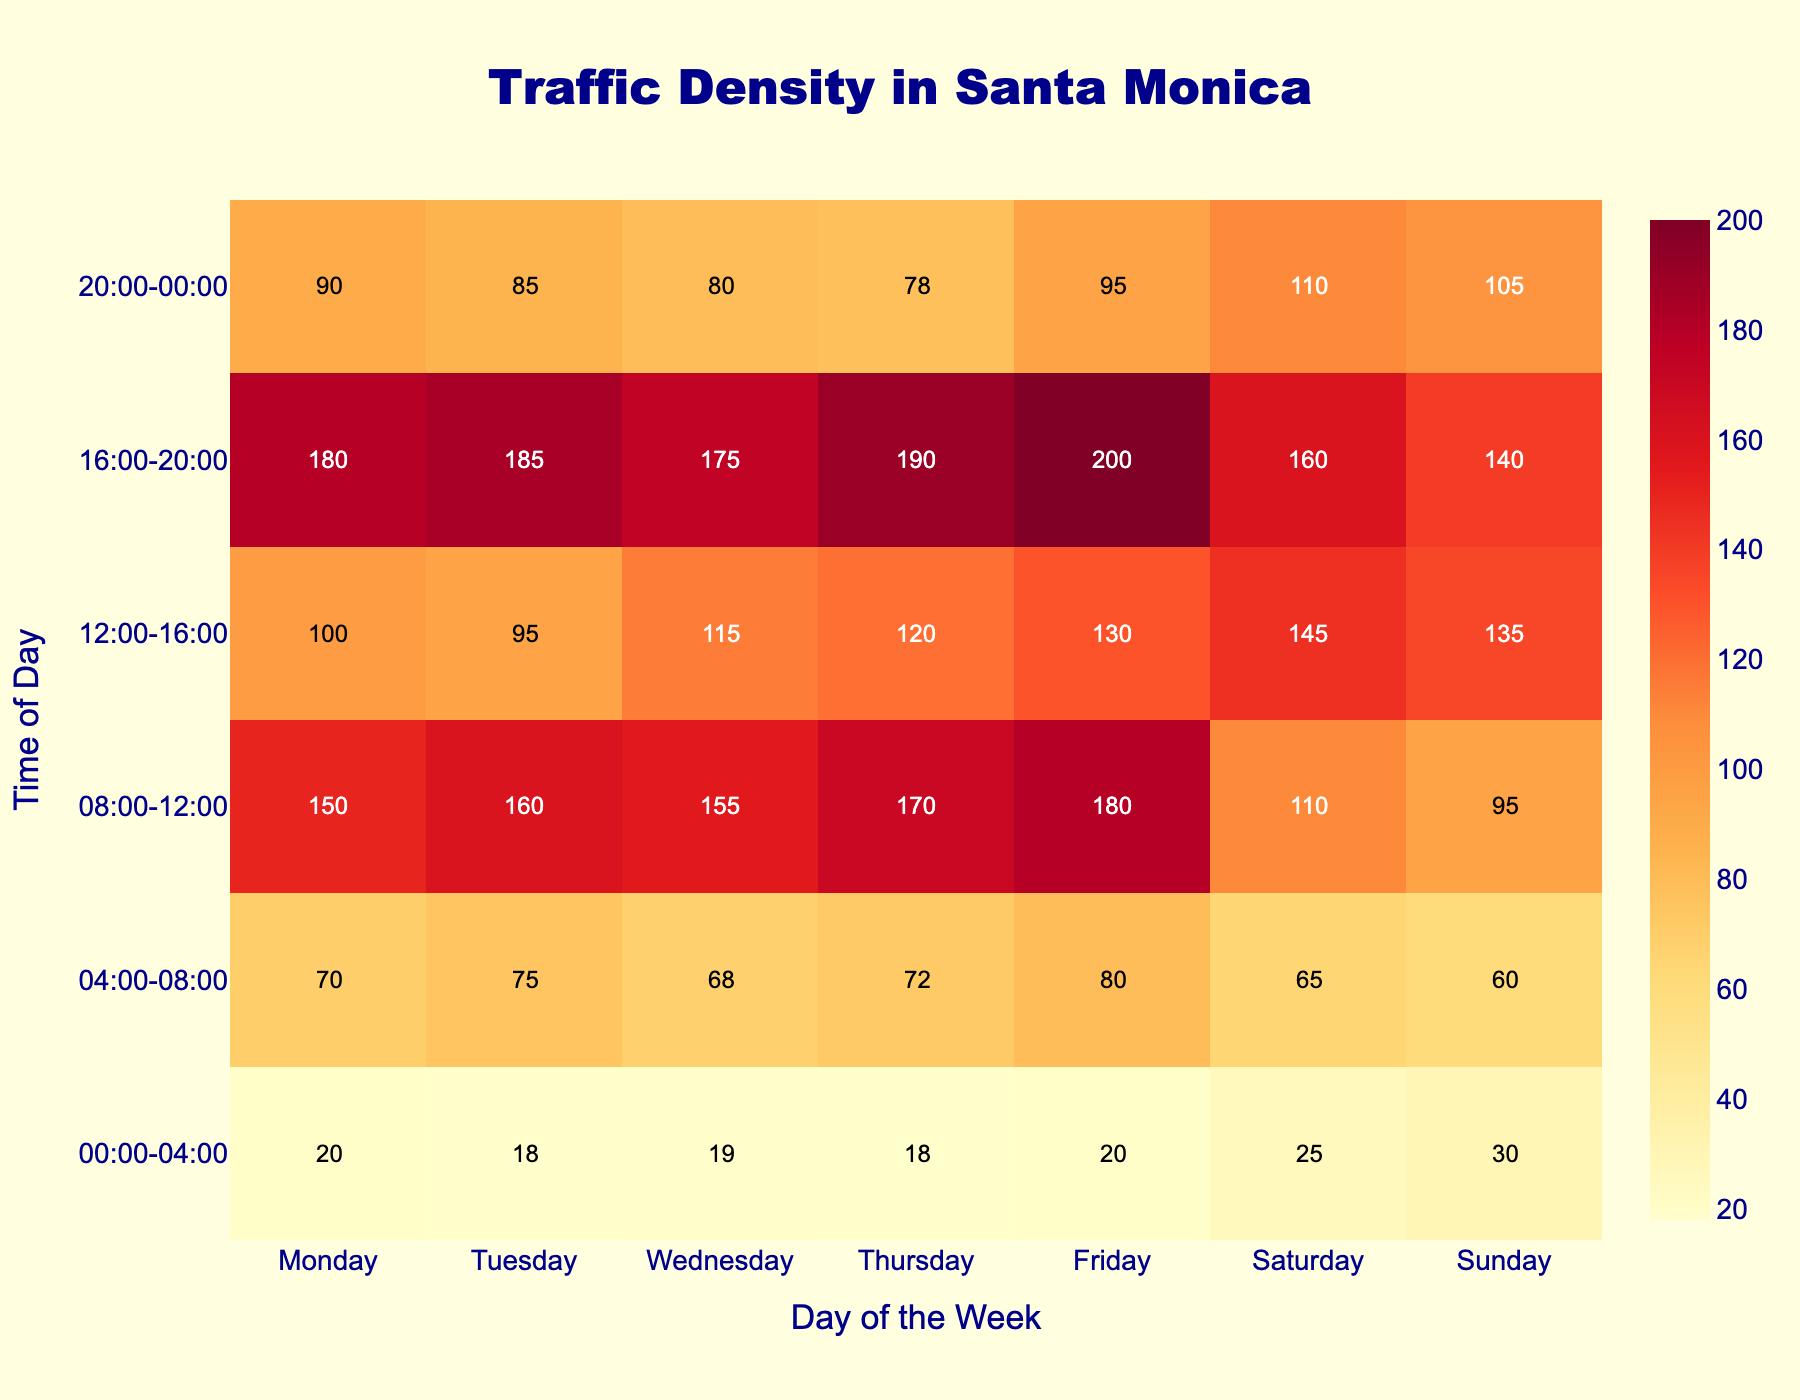What time period shows the highest traffic density on Friday? Looking at the heatmap, find the cell with the highest value under Friday. The highest number is 200, which is in the row corresponding to the 16:00-20:00 time period.
Answer: 16:00-20:00 Which day has the lowest average traffic density over all time periods? Calculate the average traffic density for each day by summing the values for each column and dividing by the number of time periods (6). The averages are: Monday (101.67), Tuesday (104.17), Wednesday (102.00), Thursday (108.00), Friday (117.50), Saturday (102.50), and Sunday (93.33). The lowest average is on Sunday.
Answer: Sunday How does the traffic density at 08:00-12:00 on weekdays compare to weekends? Average the values in the 08:00-12:00 row for weekdays (Monday to Friday) and compare it with the average for weekends (Saturday and Sunday). Weekdays: (150+160+155+170+180)/5 = 163. Weekends: (110+95)/2 = 102.5. Weekday traffic density is higher.
Answer: Weekdays are higher What is the difference in traffic density between Tuesday and Thursday at 12:00-16:00? Subtract the traffic density on Tuesday at 12:00-16:00 from the density on Thursday at the same time. 120 (Thursday) - 95 (Tuesday) = 25.
Answer: 25 Which time period shows the most variation in traffic density throughout the week? Look at each row and calculate the range (maximum value minus the minimum value) of traffic densities. The times and ranges are: 00:00-04:00 (30-18=12), 04:00-08:00 (80-60=20), 08:00-12:00 (180-95=85), 12:00-16:00 (145-95=50), 16:00-20:00 (200-140=60), and 20:00-00:00 (110-78=32). The biggest range is 08:00-12:00 with a value of 85.
Answer: 08:00-12:00 What color represents the highest traffic density in the heatmap? The color scale used in the heatmap is 'YlOrRd'. Refer to the color of the cell with the highest value (Friday, 16:00-20:00, value of 200). The color is dark red.
Answer: Dark red On which day is the traffic least variable throughout the day? Find the range (difference between the highest and lowest values) of traffic densities for each day. The ranges are: Monday (180-20=160), Tuesday (185-18=167), Wednesday (175-19=156), Thursday (190-18=172), Friday (200-20=180), Saturday (160-25=135), and Sunday (140-30=110). The smallest range is on Sunday.
Answer: Sunday 